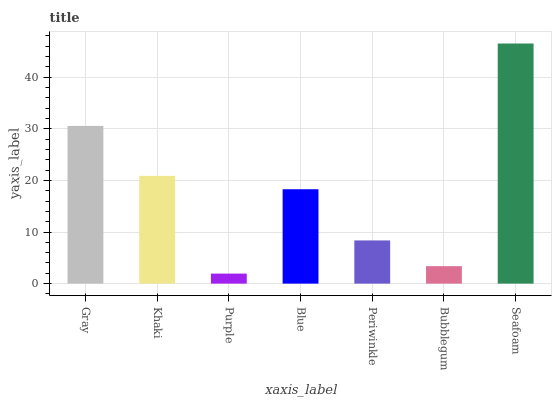Is Purple the minimum?
Answer yes or no. Yes. Is Seafoam the maximum?
Answer yes or no. Yes. Is Khaki the minimum?
Answer yes or no. No. Is Khaki the maximum?
Answer yes or no. No. Is Gray greater than Khaki?
Answer yes or no. Yes. Is Khaki less than Gray?
Answer yes or no. Yes. Is Khaki greater than Gray?
Answer yes or no. No. Is Gray less than Khaki?
Answer yes or no. No. Is Blue the high median?
Answer yes or no. Yes. Is Blue the low median?
Answer yes or no. Yes. Is Gray the high median?
Answer yes or no. No. Is Khaki the low median?
Answer yes or no. No. 